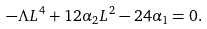Convert formula to latex. <formula><loc_0><loc_0><loc_500><loc_500>- \Lambda L ^ { 4 } + 1 2 \alpha _ { 2 } L ^ { 2 } - 2 4 \alpha _ { 1 } = 0 .</formula> 